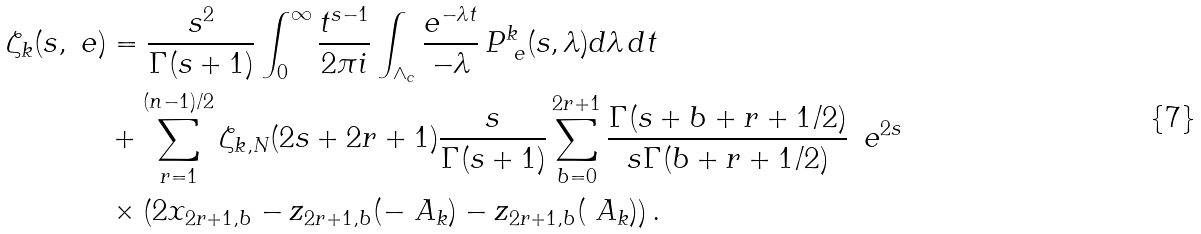<formula> <loc_0><loc_0><loc_500><loc_500>\zeta _ { k } ( s , \ e ) & = \frac { s ^ { 2 } } { \Gamma ( s + 1 ) } \int _ { 0 } ^ { \infty } \frac { t ^ { s - 1 } } { 2 \pi i } \int _ { \wedge _ { c } } \frac { e ^ { - \lambda t } } { - \lambda } \, P ^ { k } _ { \ e } ( s , \lambda ) d \lambda \, d t \\ & + \sum _ { r = 1 } ^ { ( n - 1 ) / 2 } \zeta _ { k , N } ( 2 s + 2 r + 1 ) \frac { s } { \Gamma ( s + 1 ) } \sum _ { b = 0 } ^ { 2 r + 1 } \frac { \Gamma ( s + b + r + 1 / 2 ) } { s \Gamma ( b + r + 1 / 2 ) } \, \ e ^ { 2 s } \\ & \times \left ( 2 x _ { 2 r + 1 , b } - z _ { 2 r + 1 , b } ( - \ A _ { k } ) - z _ { 2 r + 1 , b } ( \ A _ { k } ) \right ) .</formula> 